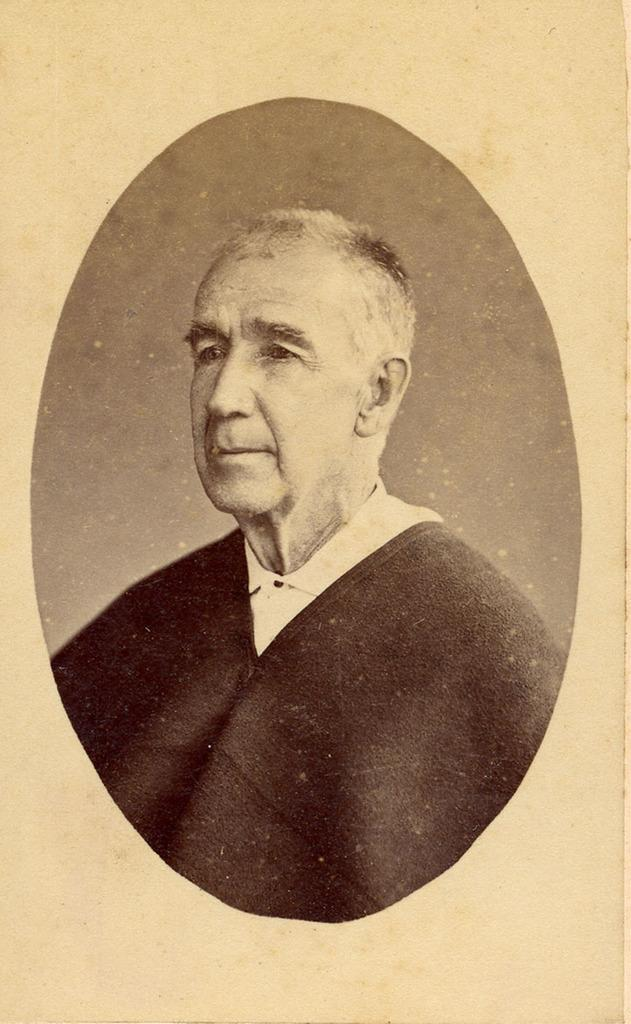What is the color scheme of the image? The image is black and white. Can you describe the person in the image? There is an old man in the image. What type of activity is the turkey engaging in during the old man's sleep? There is no turkey present in the image, and therefore no such activity can be observed. 